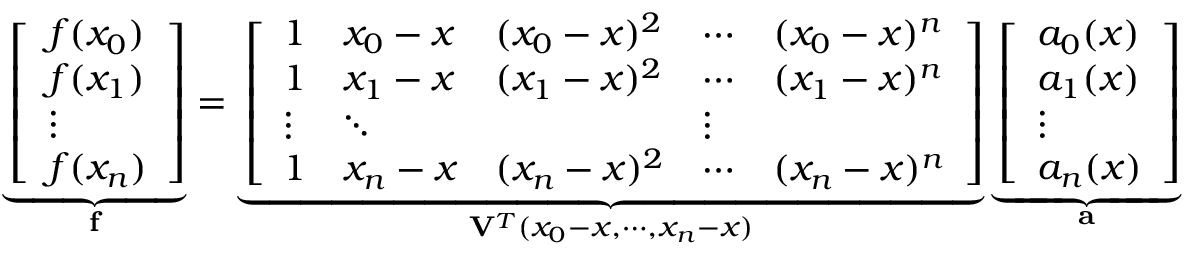<formula> <loc_0><loc_0><loc_500><loc_500>\underbrace { \left [ \begin{array} { l } { f ( x _ { 0 } ) } \\ { f ( x _ { 1 } ) } \\ { \vdots } \\ { f ( x _ { n } ) } \end{array} \right ] } _ { f } = \underbrace { \left [ \begin{array} { l l l l l } { 1 } & { x _ { 0 } - x } & { ( x _ { 0 } - x ) ^ { 2 } } & { \cdots } & { ( x _ { 0 } - x ) ^ { n } } \\ { 1 } & { x _ { 1 } - x } & { ( x _ { 1 } - x ) ^ { 2 } } & { \cdots } & { ( x _ { 1 } - x ) ^ { n } } \\ { \vdots } & { \ddots } & & { \vdots } \\ { 1 } & { x _ { n } - x } & { ( x _ { n } - x ) ^ { 2 } } & { \cdots } & { ( x _ { n } - x ) ^ { n } } \end{array} \right ] } _ { V ^ { T } ( x _ { 0 } - x , \cdots , x _ { n } - x ) } \underbrace { \left [ \begin{array} { l } { a _ { 0 } ( x ) } \\ { a _ { 1 } ( x ) } \\ { \vdots } \\ { a _ { n } ( x ) } \end{array} \right ] } _ { a }</formula> 